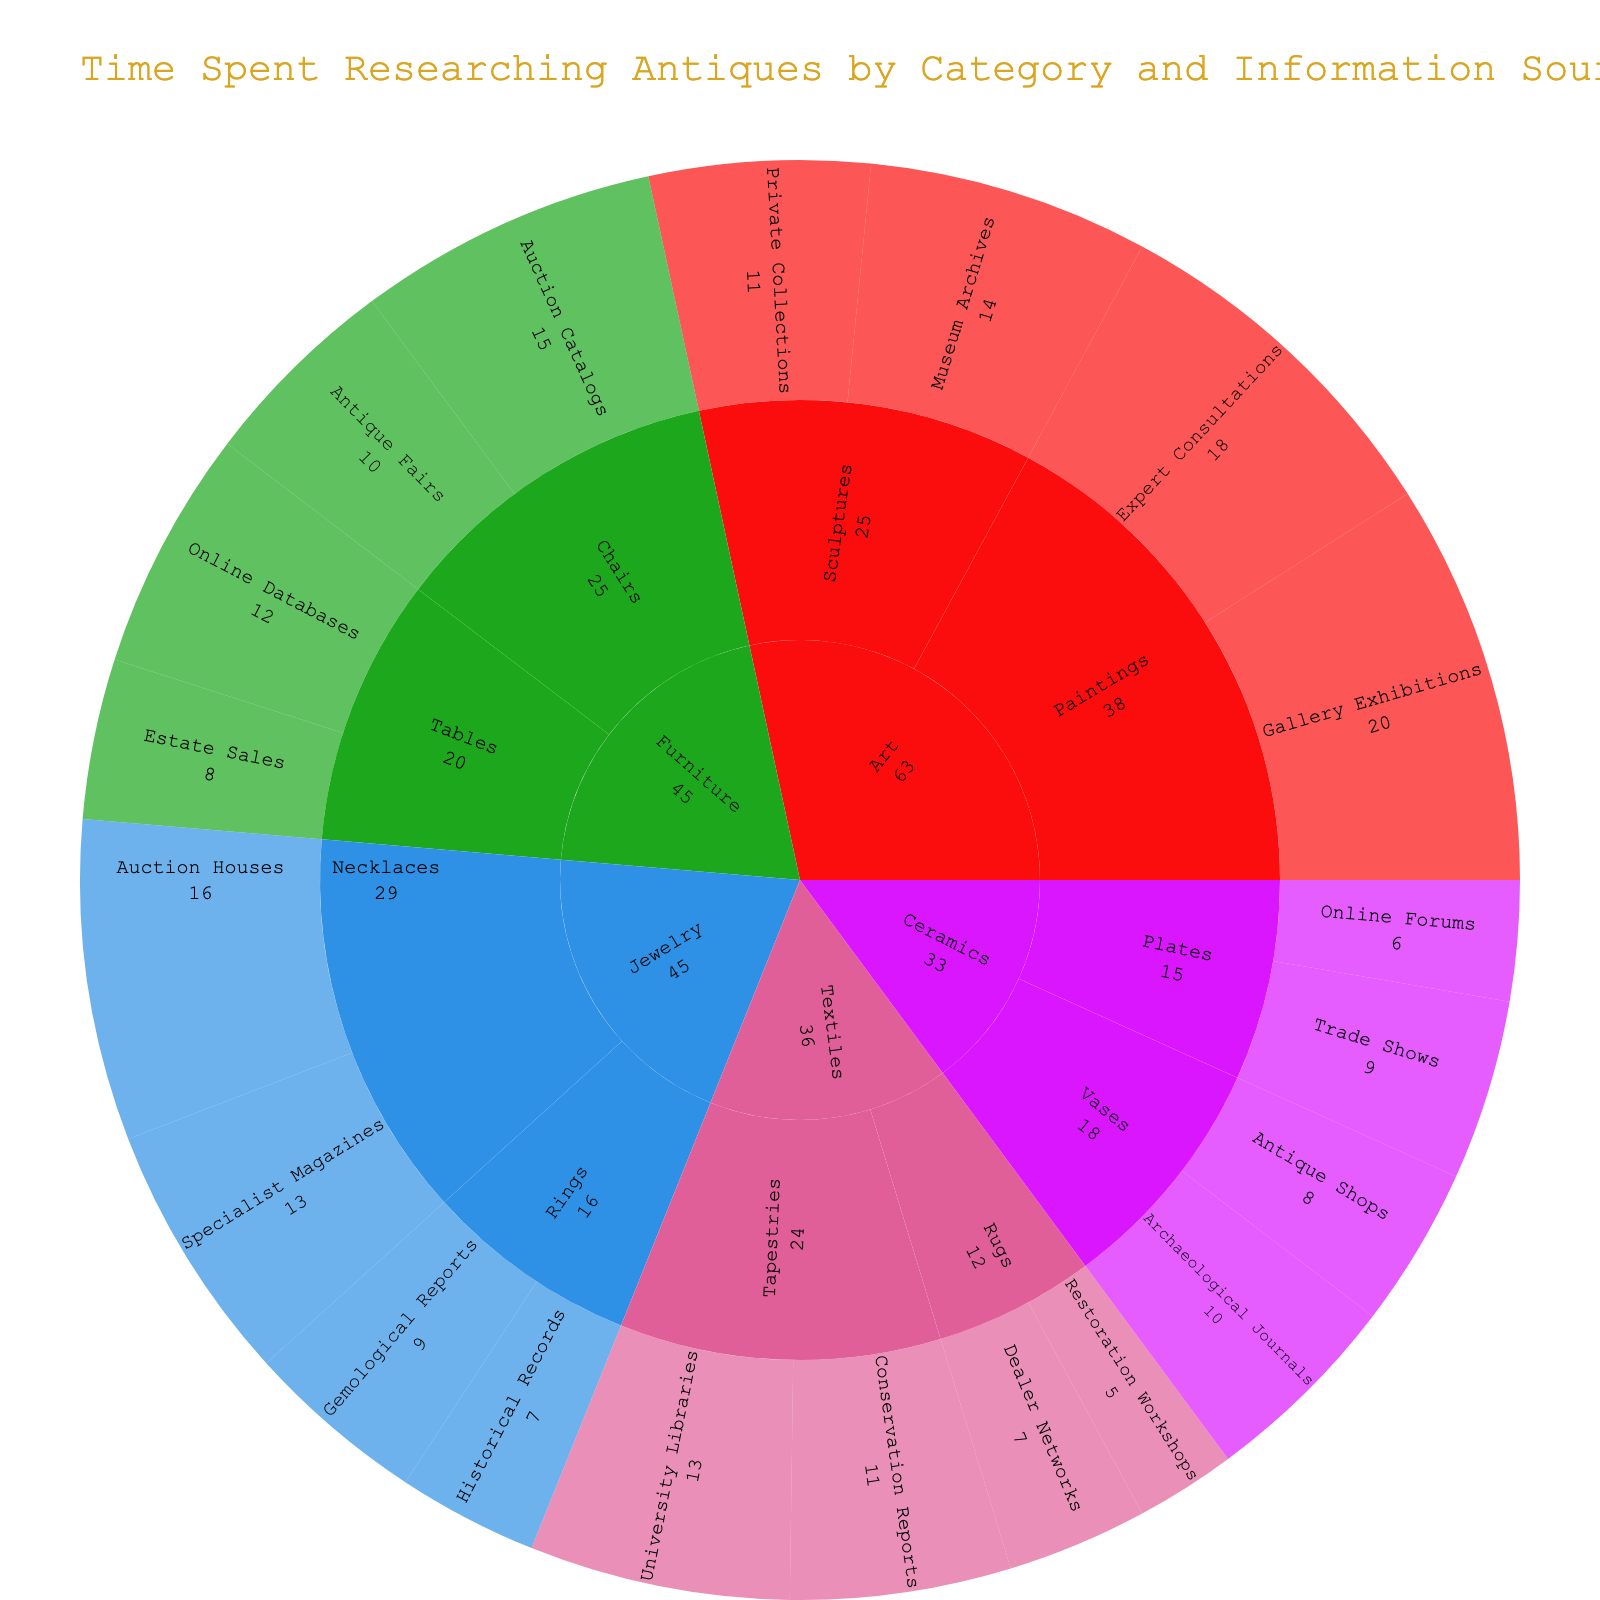What category has the highest total time spent researching? Summing the time for each source within each category, Furniture: 15+10+12+8=45, Art: 20+18+14+11=63, Jewelry: 9+7+13+16=45, Ceramics: 10+8+6+9=33, Textiles: 11+13+7+5=36. Art has the highest total time with 63 hours.
Answer: Art What subcategory of Art has the highest research time? Calculating the total time for each subcategory within Art, Paintings: 20+18=38, Sculptures: 14+11=25. Paintings have the highest total time with 38 hours.
Answer: Paintings What information source spent the most time researching Art? Looking at Art subcategories, Paintings: Gallery Exhibitions 20, Expert Consultations 18; Sculptures: Museum Archives 14, Private Collections 11. Gallery Exhibitions have the highest time with 20 hours.
Answer: Gallery Exhibitions Which category requires the least amount of research time overall? Summing the total time for each category, Ceramics has the lowest total with 33 hours.
Answer: Ceramics What is the average time spent researching Chairs in the Furniture category? Adding the times for Chairs: Auction Catalogs 15 and Antique Fairs 10. The average is (15+10)/2 = 12.5.
Answer: 12.5 Compare the total time spent on researching Tables and Chairs in the Furniture category. Which has more? Tables total: 12+8=20, Chairs total: 15+10=25. Chairs have more total time with 25 hours.
Answer: Chairs Which information source has the least time spent on it across all categories? Identifying the lowest time value among all sources, Restoration Workshops for Rugs in Textiles has 5 hours, which is the least.
Answer: Restoration Workshops How much more time is spent on researching Paintings in Art compared to Rugs in Textiles? Paintings: 20+18=38, Rugs: 7+5=12. The difference is 38-12=26 hours.
Answer: 26 Which information source was used for the highest number of different subcategories across any category? Identifying the source across different subcategories, Auction Catalogs: 1, Antique Fairs: 1, Online Databases: 1, etc. Specialist Magazines are used in Jewelry and Textiles.
Answer: Specialist Magazines What's the total time spent on Jewelry across all subcategories and sources? Adding all times for Jewelry, Rings: 9+7=16; Necklaces: 13+16. Total is (9+7+13+16)=45 hours.
Answer: 45 